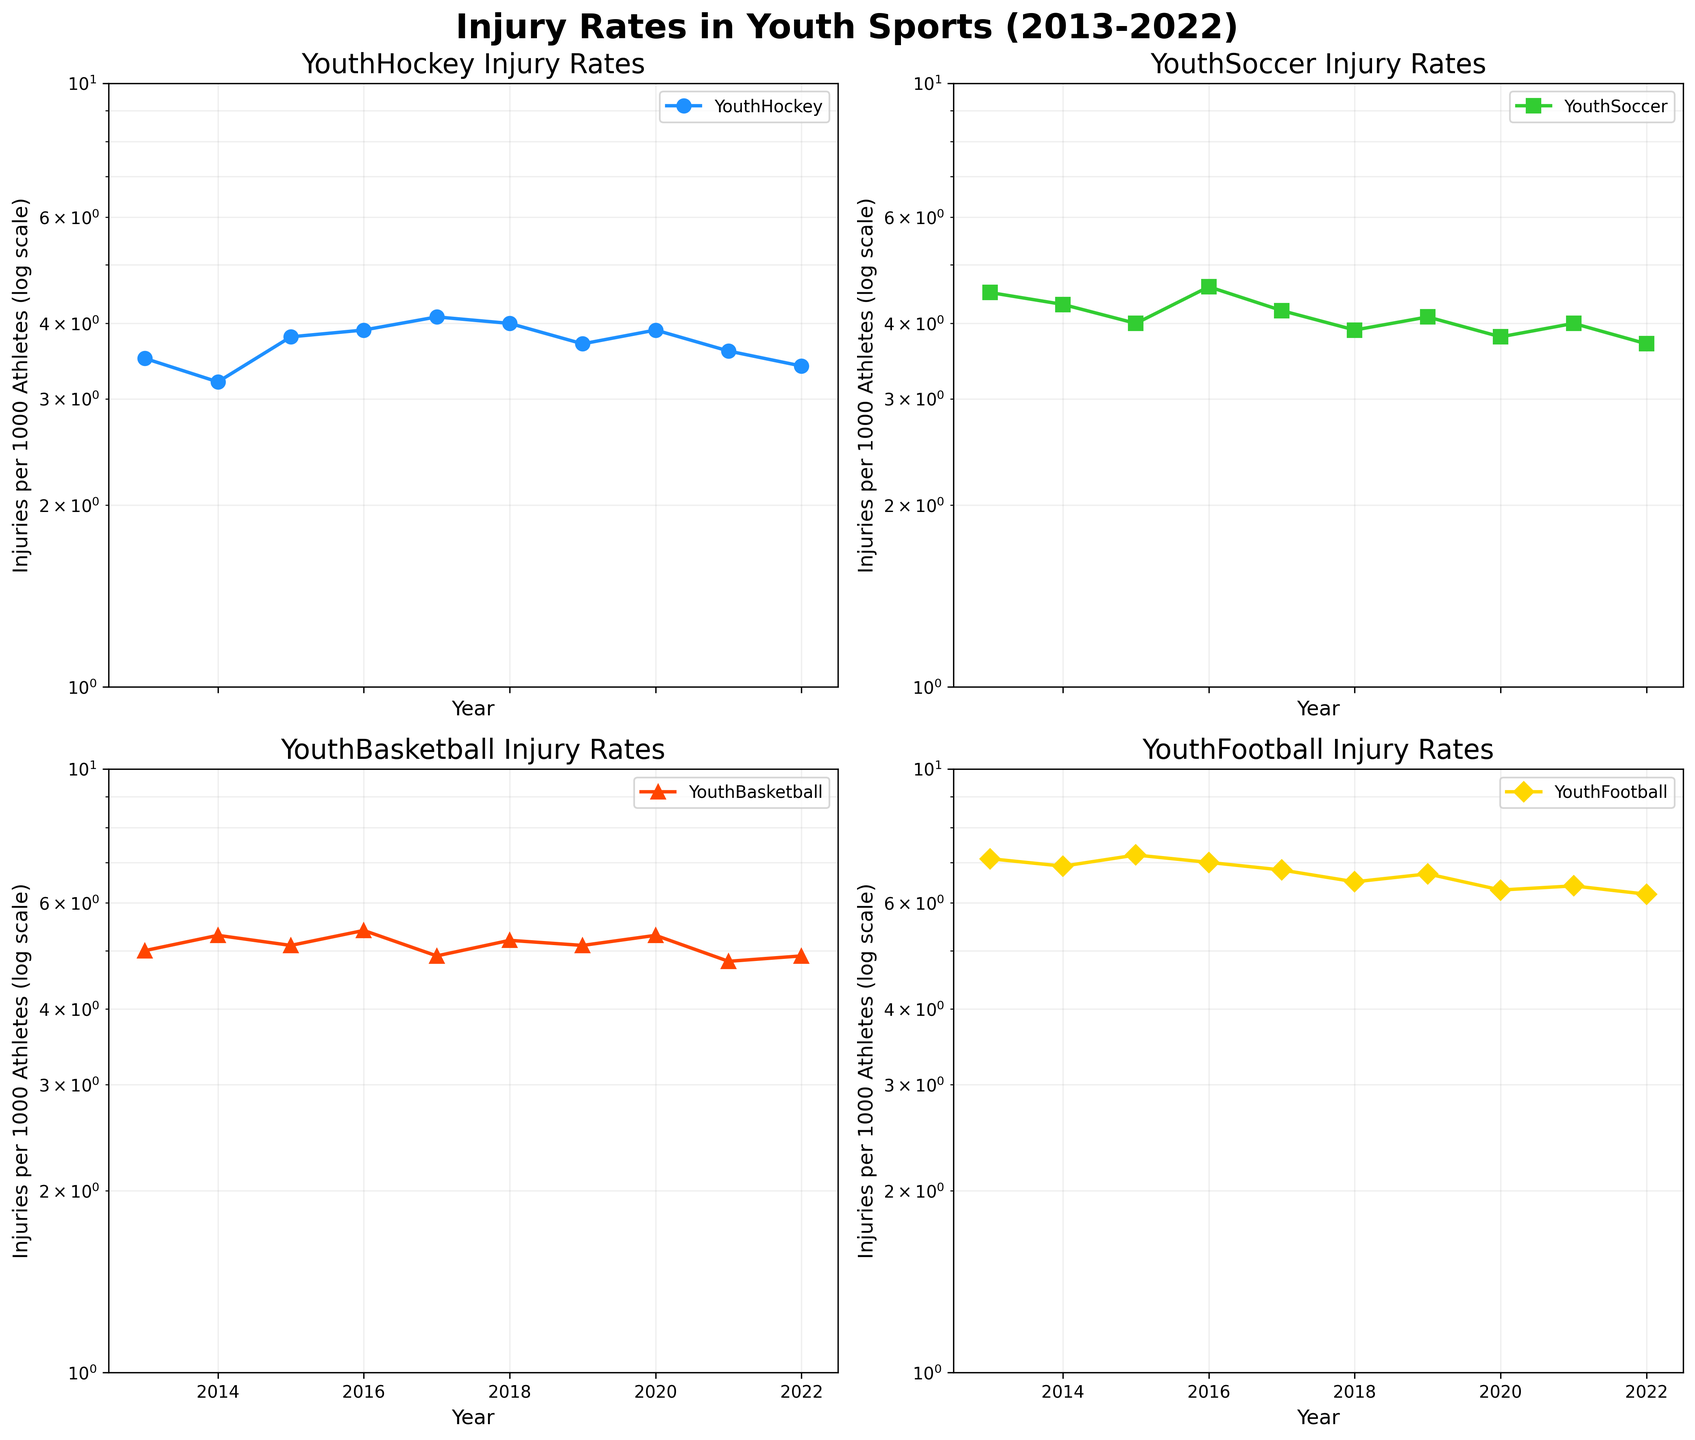What are the four sports shown in the figure? The four subplots each show a different sport. The titles of these subplots indicate the specific sports: YouthHockey, YouthSoccer, YouthBasketball, and YouthFootball.
Answer: YouthHockey, YouthSoccer, YouthBasketball, YouthFootball Which sport had the highest injury rate in 2013? By looking at the first data point for each sport in 2013, YouthFootball had the highest injury rate, shown at around 7.1 injuries per 1000 athletes.
Answer: YouthFootball In which year did YouthHockey have the lowest injury rate? By looking at the data points for YouthHockey across all years, the lowest injury rate was in 2022, where it was recorded at around 3.4 injuries per 1000 athletes.
Answer: 2022 What is the trend in injury rates for YouthBasketball from 2013 to 2022? Observing the trend line for YouthBasketball, it shows fluctuations but starts higher in 2013 then sees slight decreases and increases, roughly maintaining a similar range, ending slightly lower in 2022.
Answer: Fluctuating but roughly stable Which sport shows a generally decreasing trend in injury rates over the decade? By comparing the trend lines of all four sports, YouthFootball shows a generally decreasing trend in injury rates from 2013 to 2022.
Answer: YouthFootball How did the injury rate of YouthSoccer change from 2015 to 2016? By examining the data points for YouthSoccer between 2015 and 2016, the injury rate increased from 4.0 to 4.6 injuries per 1000 athletes.
Answer: Increased from 4.0 to 4.6 Between which two consecutive years did YouthHockey see the largest increase in injury rates? Comparing the changes between consecutive data points for YouthHockey from year to year, the largest increase occurred between 2014 (3.2) and 2015 (3.8).
Answer: 2014 and 2015 Between 2013 and 2022, which sport had the smallest range of injury rates? The range is calculated by subtracting the minimum injury rate from the maximum injury rate for each sport. YouthHockey had the smallest range, between 3.2 and 4.1.
Answer: YouthHockey Which sport had its highest injury rate in 2018? By checking the data points for 2018, YouthBasketball had a high point visible around 5.2 injuries per 1000 athletes, whereas the other sports had lower rates.
Answer: YouthBasketball 